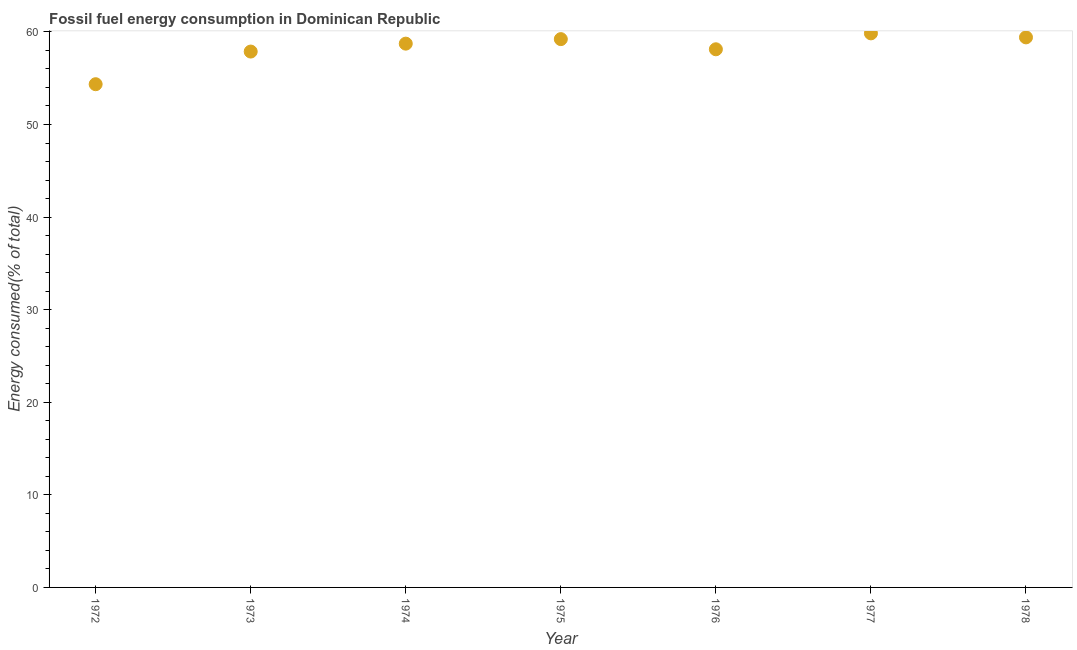What is the fossil fuel energy consumption in 1976?
Your answer should be very brief. 58.12. Across all years, what is the maximum fossil fuel energy consumption?
Offer a terse response. 59.84. Across all years, what is the minimum fossil fuel energy consumption?
Provide a short and direct response. 54.35. In which year was the fossil fuel energy consumption maximum?
Give a very brief answer. 1977. In which year was the fossil fuel energy consumption minimum?
Your answer should be compact. 1972. What is the sum of the fossil fuel energy consumption?
Ensure brevity in your answer.  407.55. What is the difference between the fossil fuel energy consumption in 1975 and 1976?
Your answer should be very brief. 1.1. What is the average fossil fuel energy consumption per year?
Your answer should be compact. 58.22. What is the median fossil fuel energy consumption?
Your answer should be compact. 58.73. In how many years, is the fossil fuel energy consumption greater than 6 %?
Your response must be concise. 7. Do a majority of the years between 1976 and 1973 (inclusive) have fossil fuel energy consumption greater than 26 %?
Offer a terse response. Yes. What is the ratio of the fossil fuel energy consumption in 1972 to that in 1973?
Provide a succinct answer. 0.94. What is the difference between the highest and the second highest fossil fuel energy consumption?
Provide a short and direct response. 0.43. Is the sum of the fossil fuel energy consumption in 1973 and 1977 greater than the maximum fossil fuel energy consumption across all years?
Make the answer very short. Yes. What is the difference between the highest and the lowest fossil fuel energy consumption?
Provide a short and direct response. 5.49. How many dotlines are there?
Make the answer very short. 1. How many years are there in the graph?
Offer a very short reply. 7. Does the graph contain any zero values?
Make the answer very short. No. Does the graph contain grids?
Provide a succinct answer. No. What is the title of the graph?
Provide a succinct answer. Fossil fuel energy consumption in Dominican Republic. What is the label or title of the Y-axis?
Offer a very short reply. Energy consumed(% of total). What is the Energy consumed(% of total) in 1972?
Ensure brevity in your answer.  54.35. What is the Energy consumed(% of total) in 1973?
Provide a succinct answer. 57.88. What is the Energy consumed(% of total) in 1974?
Make the answer very short. 58.73. What is the Energy consumed(% of total) in 1975?
Your answer should be very brief. 59.22. What is the Energy consumed(% of total) in 1976?
Give a very brief answer. 58.12. What is the Energy consumed(% of total) in 1977?
Offer a terse response. 59.84. What is the Energy consumed(% of total) in 1978?
Offer a very short reply. 59.41. What is the difference between the Energy consumed(% of total) in 1972 and 1973?
Offer a terse response. -3.53. What is the difference between the Energy consumed(% of total) in 1972 and 1974?
Provide a succinct answer. -4.38. What is the difference between the Energy consumed(% of total) in 1972 and 1975?
Make the answer very short. -4.87. What is the difference between the Energy consumed(% of total) in 1972 and 1976?
Your answer should be very brief. -3.77. What is the difference between the Energy consumed(% of total) in 1972 and 1977?
Give a very brief answer. -5.49. What is the difference between the Energy consumed(% of total) in 1972 and 1978?
Provide a short and direct response. -5.06. What is the difference between the Energy consumed(% of total) in 1973 and 1974?
Provide a short and direct response. -0.86. What is the difference between the Energy consumed(% of total) in 1973 and 1975?
Provide a succinct answer. -1.34. What is the difference between the Energy consumed(% of total) in 1973 and 1976?
Offer a terse response. -0.25. What is the difference between the Energy consumed(% of total) in 1973 and 1977?
Ensure brevity in your answer.  -1.96. What is the difference between the Energy consumed(% of total) in 1973 and 1978?
Your answer should be compact. -1.53. What is the difference between the Energy consumed(% of total) in 1974 and 1975?
Your answer should be very brief. -0.49. What is the difference between the Energy consumed(% of total) in 1974 and 1976?
Offer a terse response. 0.61. What is the difference between the Energy consumed(% of total) in 1974 and 1977?
Ensure brevity in your answer.  -1.11. What is the difference between the Energy consumed(% of total) in 1974 and 1978?
Your answer should be compact. -0.68. What is the difference between the Energy consumed(% of total) in 1975 and 1976?
Your response must be concise. 1.1. What is the difference between the Energy consumed(% of total) in 1975 and 1977?
Your answer should be compact. -0.62. What is the difference between the Energy consumed(% of total) in 1975 and 1978?
Keep it short and to the point. -0.19. What is the difference between the Energy consumed(% of total) in 1976 and 1977?
Ensure brevity in your answer.  -1.72. What is the difference between the Energy consumed(% of total) in 1976 and 1978?
Provide a succinct answer. -1.29. What is the difference between the Energy consumed(% of total) in 1977 and 1978?
Make the answer very short. 0.43. What is the ratio of the Energy consumed(% of total) in 1972 to that in 1973?
Your response must be concise. 0.94. What is the ratio of the Energy consumed(% of total) in 1972 to that in 1974?
Provide a short and direct response. 0.93. What is the ratio of the Energy consumed(% of total) in 1972 to that in 1975?
Your answer should be compact. 0.92. What is the ratio of the Energy consumed(% of total) in 1972 to that in 1976?
Make the answer very short. 0.94. What is the ratio of the Energy consumed(% of total) in 1972 to that in 1977?
Give a very brief answer. 0.91. What is the ratio of the Energy consumed(% of total) in 1972 to that in 1978?
Your answer should be compact. 0.92. What is the ratio of the Energy consumed(% of total) in 1973 to that in 1974?
Make the answer very short. 0.98. What is the ratio of the Energy consumed(% of total) in 1973 to that in 1975?
Make the answer very short. 0.98. What is the ratio of the Energy consumed(% of total) in 1973 to that in 1978?
Make the answer very short. 0.97. What is the ratio of the Energy consumed(% of total) in 1974 to that in 1975?
Make the answer very short. 0.99. What is the ratio of the Energy consumed(% of total) in 1974 to that in 1978?
Ensure brevity in your answer.  0.99. What is the ratio of the Energy consumed(% of total) in 1975 to that in 1976?
Offer a terse response. 1.02. What is the ratio of the Energy consumed(% of total) in 1976 to that in 1978?
Give a very brief answer. 0.98. What is the ratio of the Energy consumed(% of total) in 1977 to that in 1978?
Your answer should be very brief. 1.01. 